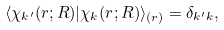<formula> <loc_0><loc_0><loc_500><loc_500>\langle \chi _ { k ^ { \prime } } ( r ; R ) | \chi _ { k } ( r ; R ) \rangle _ { ( r ) } = \delta _ { k ^ { \prime } k } ,</formula> 